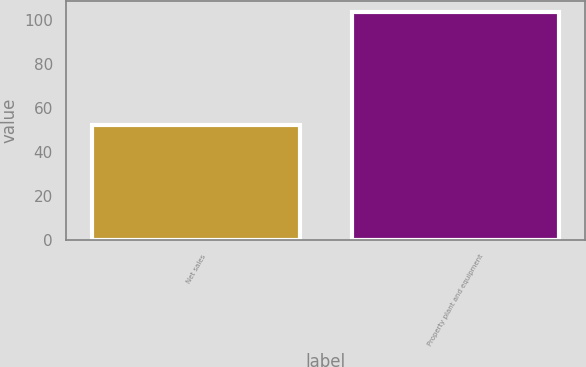Convert chart. <chart><loc_0><loc_0><loc_500><loc_500><bar_chart><fcel>Net sales<fcel>Property plant and equipment<nl><fcel>52.4<fcel>103.4<nl></chart> 